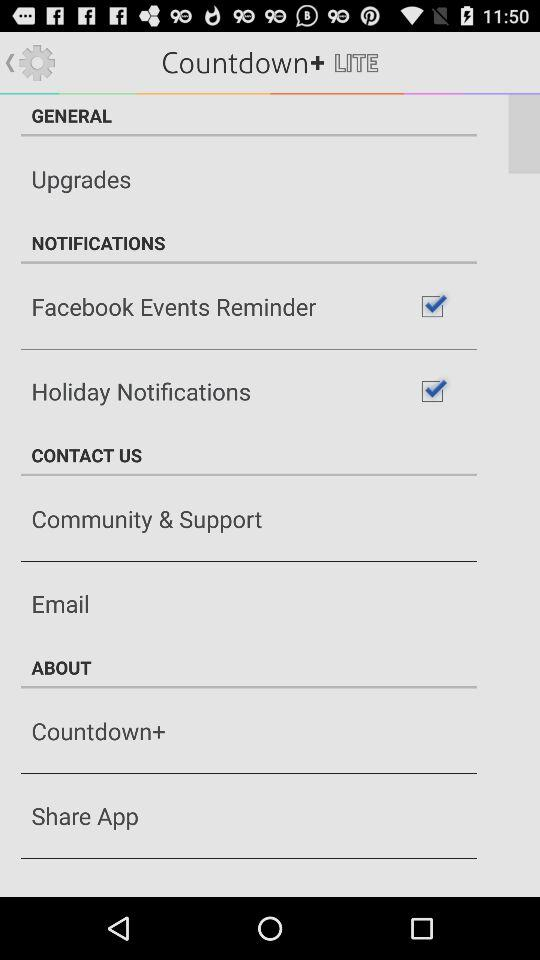Is the "Holiday Notifications" checkbox checked or not? The "Holiday Notifications" checkbox is checked. 